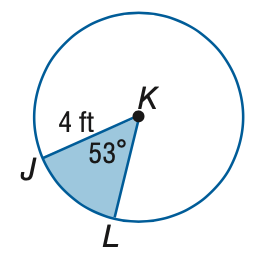Answer the mathemtical geometry problem and directly provide the correct option letter.
Question: Find the area of the shaded sector. Round to the nearest tenth.
Choices: A: 7.4 B: 21.4 C: 42.9 D: 50.3 A 